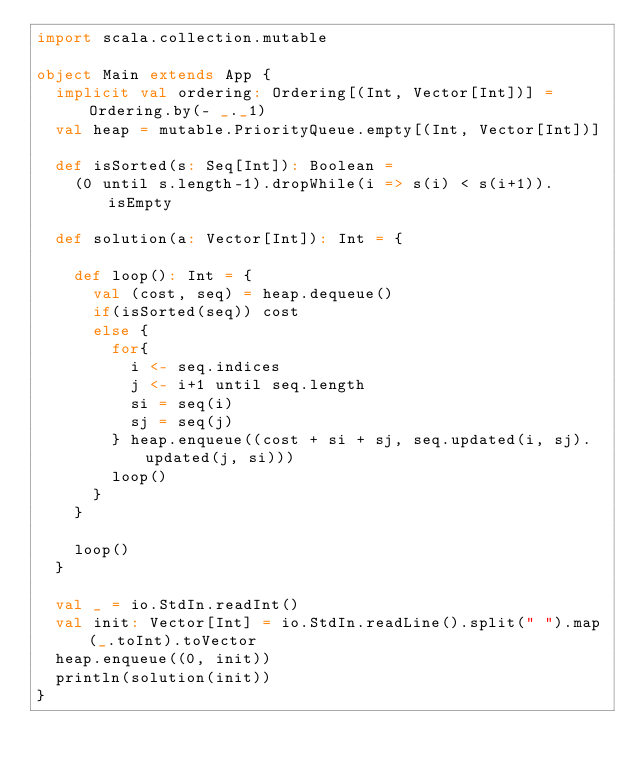Convert code to text. <code><loc_0><loc_0><loc_500><loc_500><_Scala_>import scala.collection.mutable

object Main extends App {
  implicit val ordering: Ordering[(Int, Vector[Int])] = Ordering.by(- _._1)
  val heap = mutable.PriorityQueue.empty[(Int, Vector[Int])]

  def isSorted(s: Seq[Int]): Boolean =
    (0 until s.length-1).dropWhile(i => s(i) < s(i+1)).isEmpty

  def solution(a: Vector[Int]): Int = {

    def loop(): Int = {
      val (cost, seq) = heap.dequeue()
      if(isSorted(seq)) cost
      else {
        for{
          i <- seq.indices
          j <- i+1 until seq.length
          si = seq(i)
          sj = seq(j)
        } heap.enqueue((cost + si + sj, seq.updated(i, sj).updated(j, si)))
        loop()
      }
    }

    loop()
  }

  val _ = io.StdIn.readInt()
  val init: Vector[Int] = io.StdIn.readLine().split(" ").map(_.toInt).toVector
  heap.enqueue((0, init))
  println(solution(init))
}</code> 